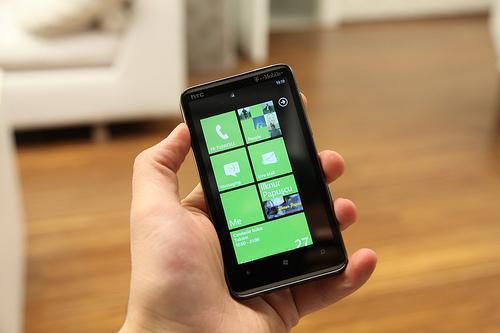How many phones are there?
Give a very brief answer. 1. 